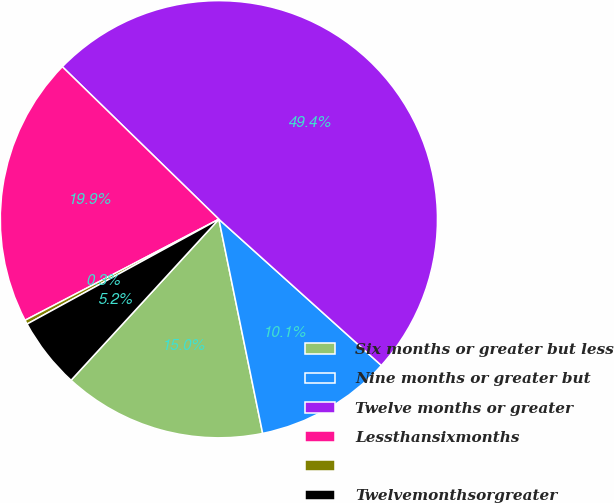Convert chart. <chart><loc_0><loc_0><loc_500><loc_500><pie_chart><fcel>Six months or greater but less<fcel>Nine months or greater but<fcel>Twelve months or greater<fcel>Lessthansixmonths<fcel>Unnamed: 4<fcel>Twelvemonthsorgreater<nl><fcel>15.03%<fcel>10.13%<fcel>49.37%<fcel>19.94%<fcel>0.31%<fcel>5.22%<nl></chart> 